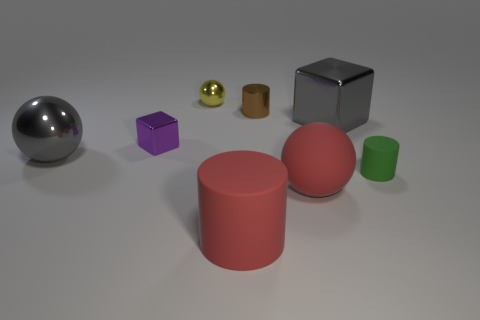Is there another thing made of the same material as the small brown thing?
Your answer should be very brief. Yes. What is the color of the tiny shiny object that is to the left of the small brown cylinder and behind the big gray shiny block?
Give a very brief answer. Yellow. How many other things are the same color as the small matte object?
Make the answer very short. 0. There is a small cylinder that is behind the purple cube that is in front of the cylinder behind the tiny green cylinder; what is it made of?
Make the answer very short. Metal. How many balls are small yellow things or matte objects?
Provide a succinct answer. 2. Is there any other thing that is the same size as the yellow shiny thing?
Offer a terse response. Yes. There is a big shiny object on the right side of the rubber cylinder to the left of the tiny green rubber cylinder; how many tiny green cylinders are in front of it?
Provide a short and direct response. 1. Do the yellow shiny thing and the tiny brown thing have the same shape?
Your answer should be compact. No. Is the tiny thing behind the small brown metal cylinder made of the same material as the big sphere that is to the right of the purple object?
Your response must be concise. No. How many objects are big gray shiny things right of the big red sphere or gray objects that are to the left of the large red sphere?
Make the answer very short. 2. 